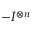<formula> <loc_0><loc_0><loc_500><loc_500>- I ^ { \otimes n }</formula> 